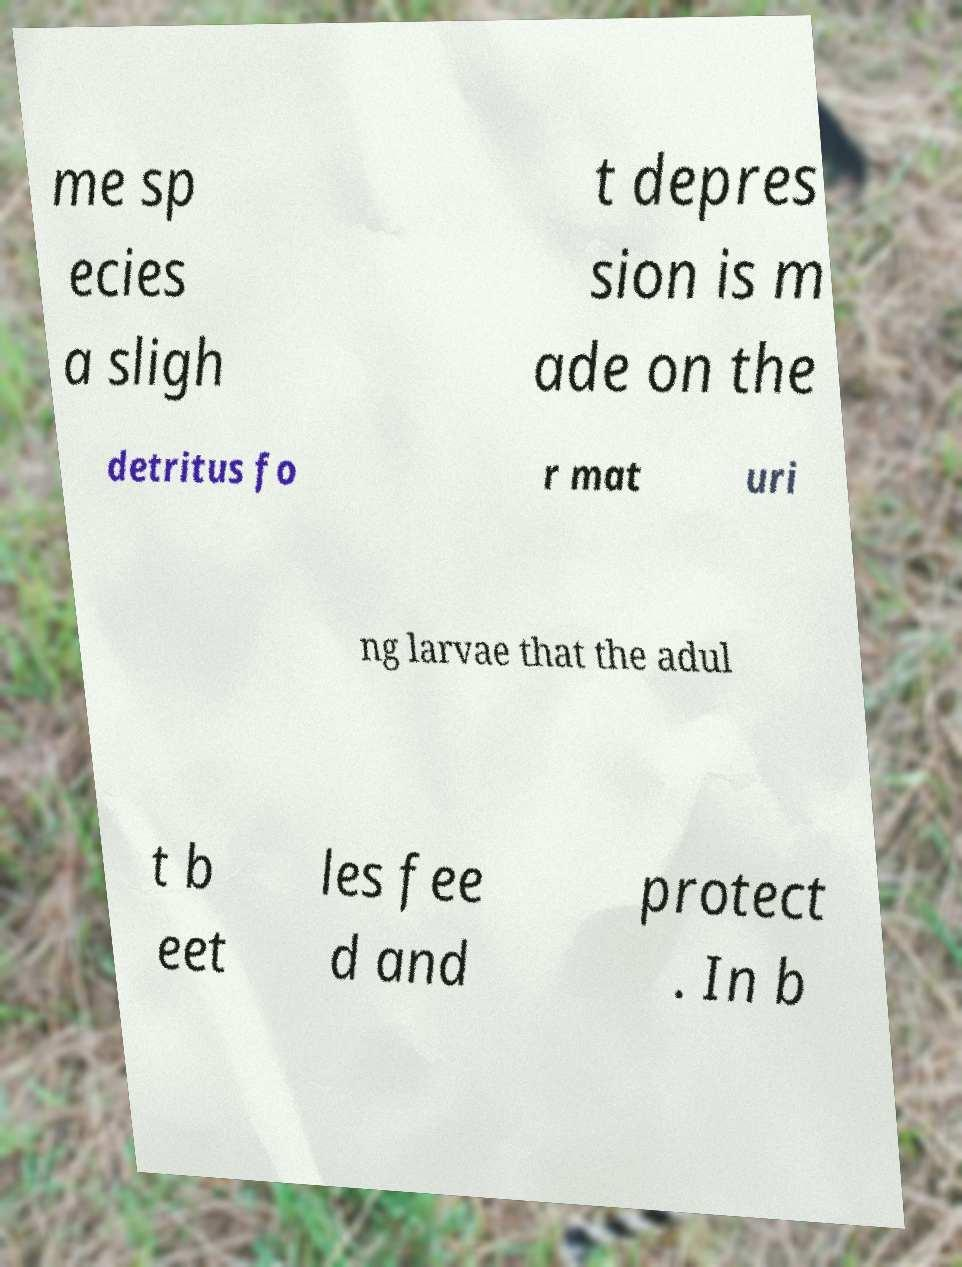Could you assist in decoding the text presented in this image and type it out clearly? me sp ecies a sligh t depres sion is m ade on the detritus fo r mat uri ng larvae that the adul t b eet les fee d and protect . In b 